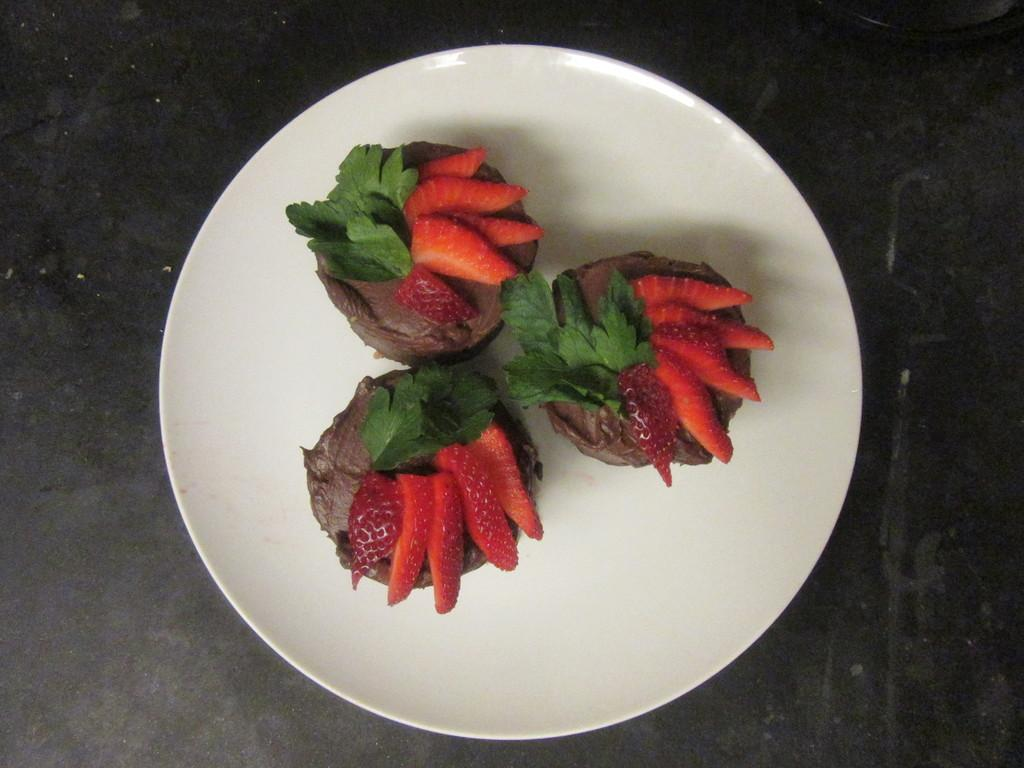What is located in the center of the image? There is a plate in the center of the image. What is on the plate? The plate contains some fruits. What can be seen in the background of the image? There is a table in the background of the image. How many snakes are slithering on the table in the image? There are no snakes present in the image; it only features a plate with fruits and a table in the background. 